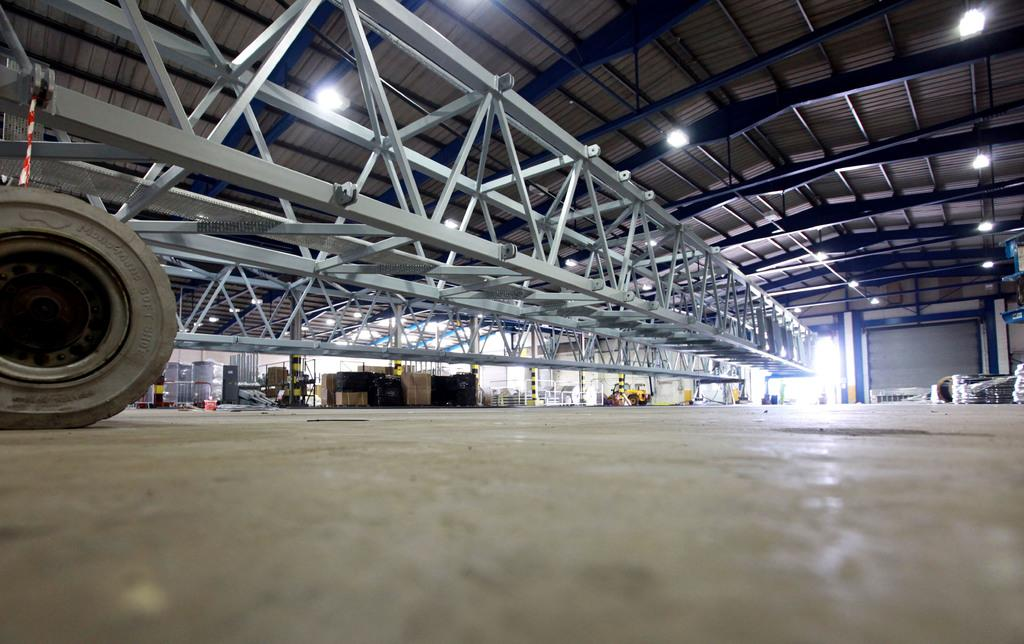What type of location is depicted in the image? The image is an inner view of a building. What objects can be seen in the building? There are tiresome poles, containers on the floor, a shutter, a metal frame, and ceiling lights in the building. What is the building's structure like? The building has a roof. What type of lettuce is being used as a calculator in the image? There is no lettuce or calculator present in the image. Can you tell me how many men are visible in the image? There are no men visible in the image; it depicts an inner view of a building with various objects and features. 